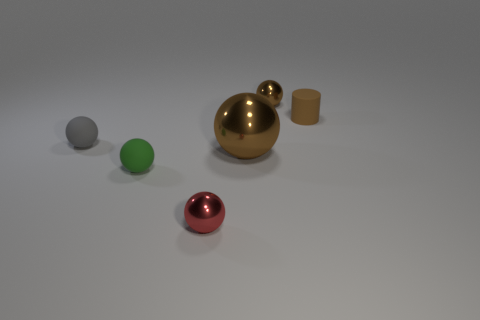Subtract all blue blocks. How many brown spheres are left? 2 Subtract all brown spheres. How many spheres are left? 3 Add 4 big red rubber things. How many objects exist? 10 Subtract all brown balls. How many balls are left? 3 Subtract all balls. How many objects are left? 1 Subtract all cyan balls. Subtract all red cylinders. How many balls are left? 5 Add 6 tiny gray rubber things. How many tiny gray rubber things exist? 7 Subtract 0 red cubes. How many objects are left? 6 Subtract all large gray blocks. Subtract all brown metallic things. How many objects are left? 4 Add 3 matte cylinders. How many matte cylinders are left? 4 